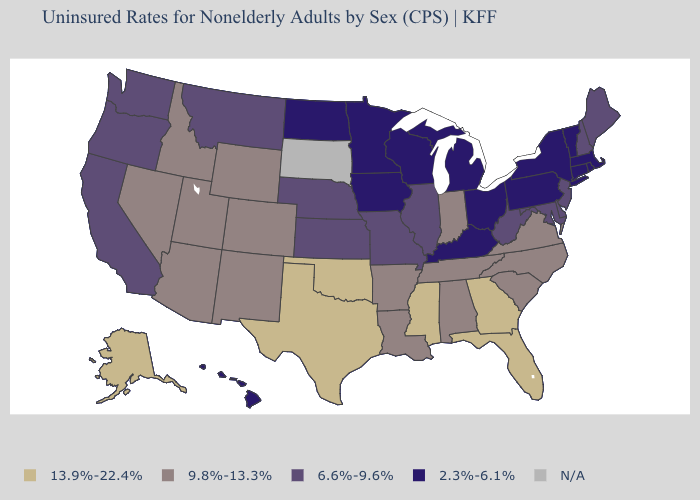What is the value of Wisconsin?
Short answer required. 2.3%-6.1%. Name the states that have a value in the range 13.9%-22.4%?
Write a very short answer. Alaska, Florida, Georgia, Mississippi, Oklahoma, Texas. Among the states that border Pennsylvania , which have the lowest value?
Give a very brief answer. New York, Ohio. What is the value of South Carolina?
Answer briefly. 9.8%-13.3%. What is the value of Wyoming?
Short answer required. 9.8%-13.3%. Name the states that have a value in the range 13.9%-22.4%?
Short answer required. Alaska, Florida, Georgia, Mississippi, Oklahoma, Texas. What is the value of Texas?
Keep it brief. 13.9%-22.4%. Name the states that have a value in the range 6.6%-9.6%?
Short answer required. California, Delaware, Illinois, Kansas, Maine, Maryland, Missouri, Montana, Nebraska, New Hampshire, New Jersey, Oregon, Washington, West Virginia. What is the value of Kansas?
Keep it brief. 6.6%-9.6%. Name the states that have a value in the range 2.3%-6.1%?
Give a very brief answer. Connecticut, Hawaii, Iowa, Kentucky, Massachusetts, Michigan, Minnesota, New York, North Dakota, Ohio, Pennsylvania, Rhode Island, Vermont, Wisconsin. What is the highest value in the South ?
Be succinct. 13.9%-22.4%. Name the states that have a value in the range 2.3%-6.1%?
Quick response, please. Connecticut, Hawaii, Iowa, Kentucky, Massachusetts, Michigan, Minnesota, New York, North Dakota, Ohio, Pennsylvania, Rhode Island, Vermont, Wisconsin. Is the legend a continuous bar?
Answer briefly. No. Name the states that have a value in the range 13.9%-22.4%?
Short answer required. Alaska, Florida, Georgia, Mississippi, Oklahoma, Texas. What is the value of Minnesota?
Give a very brief answer. 2.3%-6.1%. 